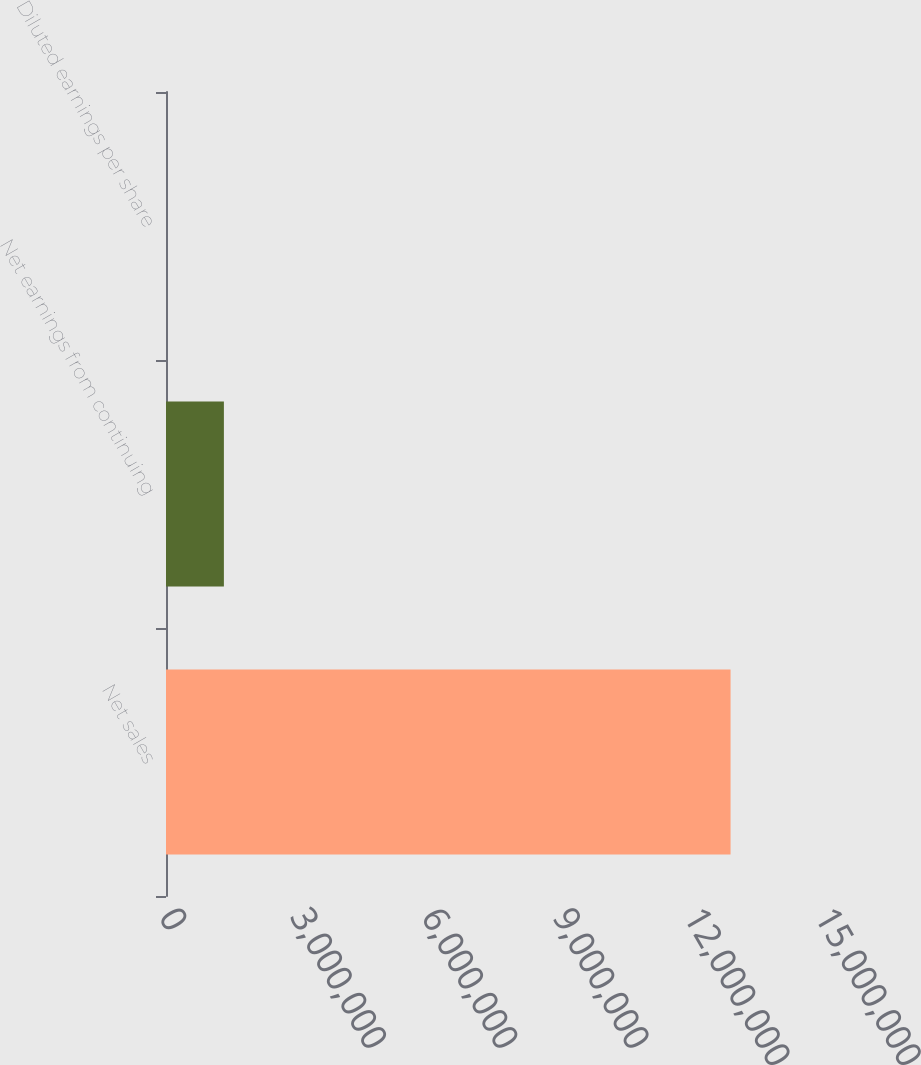<chart> <loc_0><loc_0><loc_500><loc_500><bar_chart><fcel>Net sales<fcel>Net earnings from continuing<fcel>Diluted earnings per share<nl><fcel>1.29095e+07<fcel>1.32375e+06<fcel>3.97<nl></chart> 